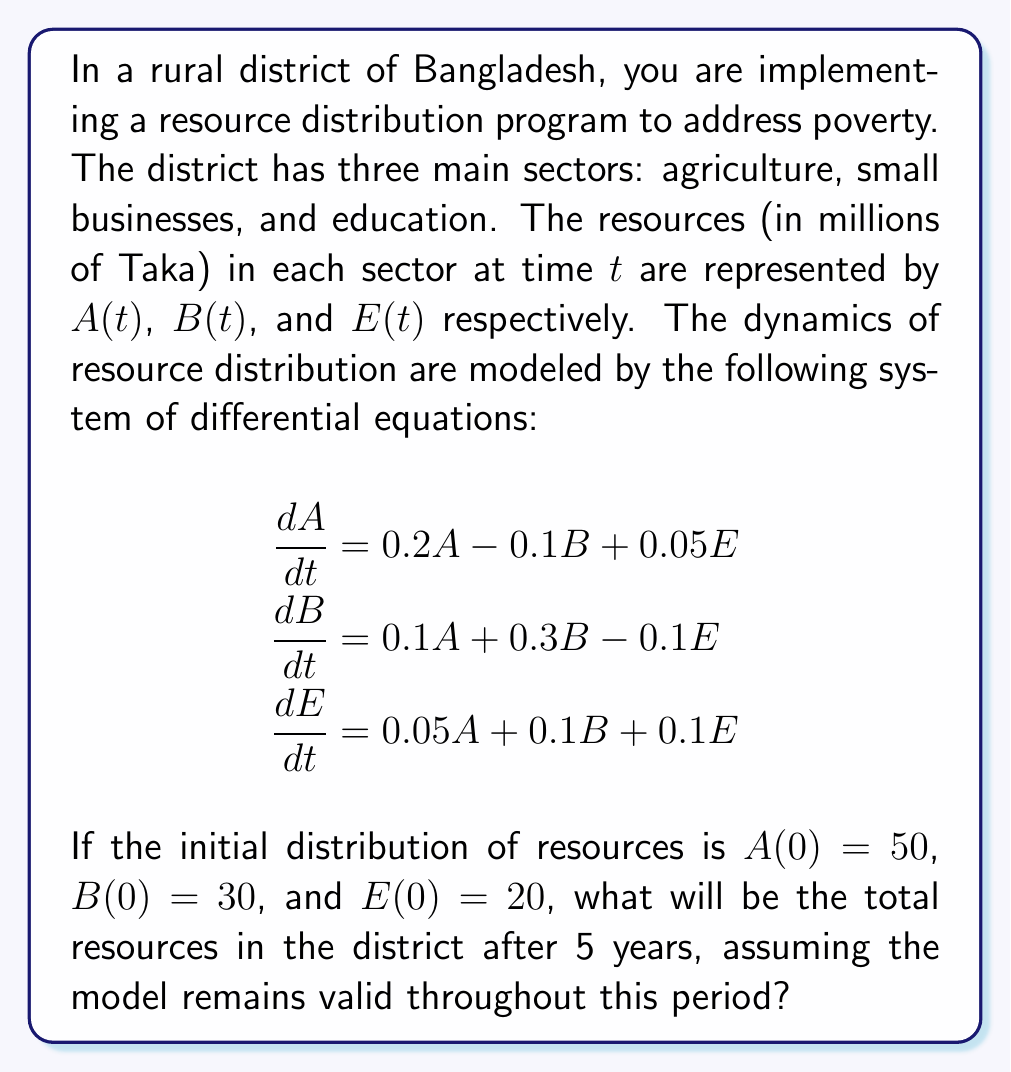Give your solution to this math problem. To solve this problem, we need to use the concept of eigenvalues and eigenvectors for systems of differential equations. Let's approach this step-by-step:

1) First, we write the system in matrix form:

   $$\frac{d}{dt}\begin{bmatrix} A \\ B \\ E \end{bmatrix} = \begin{bmatrix} 0.2 & -0.1 & 0.05 \\ 0.1 & 0.3 & -0.1 \\ 0.05 & 0.1 & 0.1 \end{bmatrix}\begin{bmatrix} A \\ B \\ E \end{bmatrix}$$

2) Let's call the matrix $M$. We need to find the eigenvalues of $M$ by solving the characteristic equation:

   $$det(M - \lambda I) = 0$$

3) This gives us the characteristic polynomial:

   $$-\lambda^3 + 0.6\lambda^2 + 0.0525\lambda + 0.005 = 0$$

4) Solving this (using a computer algebra system), we get the eigenvalues:
   $\lambda_1 \approx 0.5221$, $\lambda_2 \approx 0.0584$, $\lambda_3 \approx 0.0195$

5) For each eigenvalue, we find the corresponding eigenvector $v_i$.

6) The general solution is of the form:

   $$\begin{bmatrix} A(t) \\ B(t) \\ E(t) \end{bmatrix} = c_1e^{\lambda_1t}v_1 + c_2e^{\lambda_2t}v_2 + c_3e^{\lambda_3t}v_3$$

7) We use the initial conditions to find $c_1$, $c_2$, and $c_3$.

8) After 5 years (t = 5), we can calculate $A(5)$, $B(5)$, and $E(5)$.

9) The total resources after 5 years is $A(5) + B(5) + E(5)$.

Using a computer algebra system to perform these calculations, we get:

$A(5) \approx 64.8$
$B(5) \approx 47.2$
$E(5) \approx 31.0$

The total resources after 5 years is approximately 143.0 million Taka.
Answer: 143.0 million Taka 